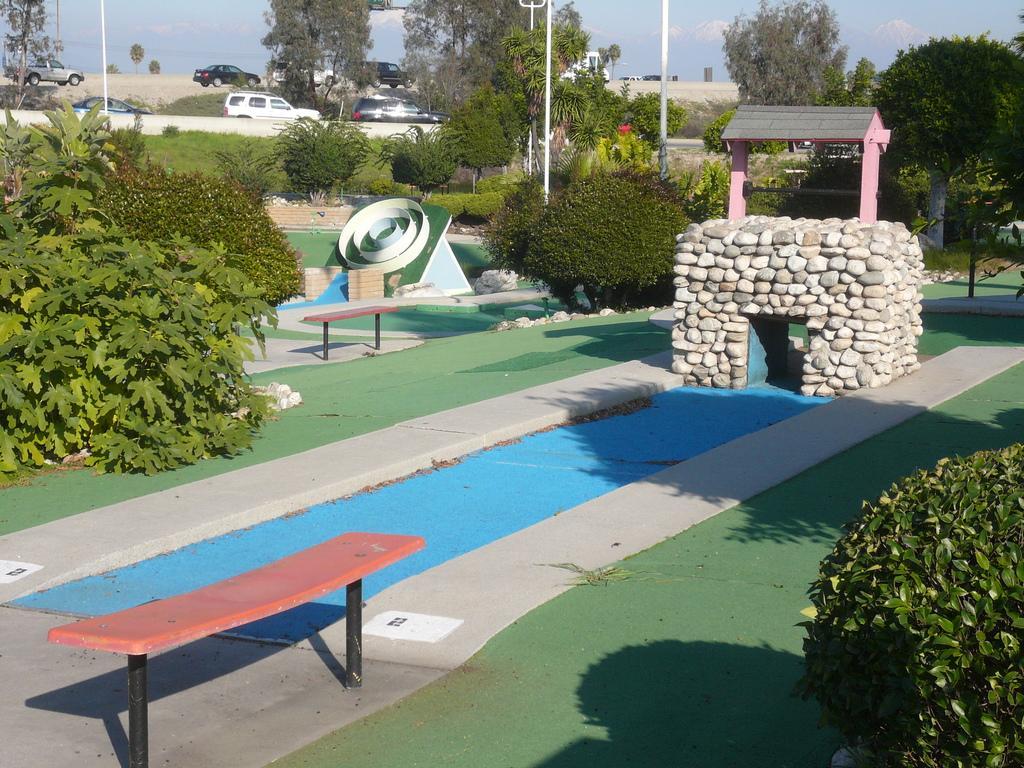Can you describe this image briefly? In this image I can see the ground, a bench, few plants which are green in color, a structure which is made up rocks, few trees and few vehicles. In the background I can see the sky. 